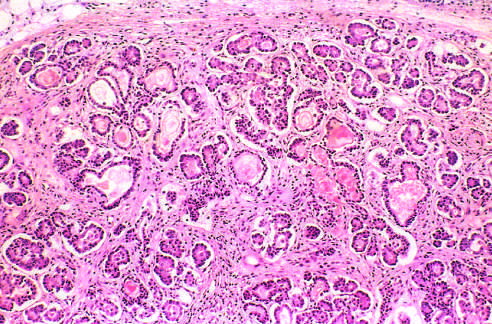what are the ducts dilated and plugged with?
Answer the question using a single word or phrase. Eosinophilic mucin 